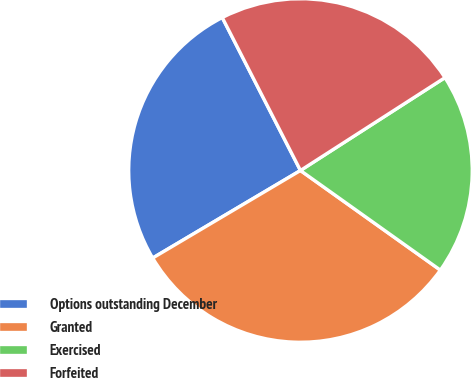Convert chart. <chart><loc_0><loc_0><loc_500><loc_500><pie_chart><fcel>Options outstanding December<fcel>Granted<fcel>Exercised<fcel>Forfeited<nl><fcel>25.99%<fcel>31.64%<fcel>18.94%<fcel>23.43%<nl></chart> 